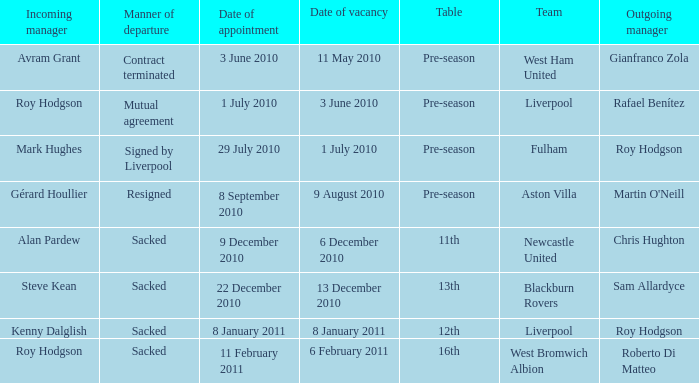What is the date of vacancy for the Liverpool team with a table named pre-season? 3 June 2010. 